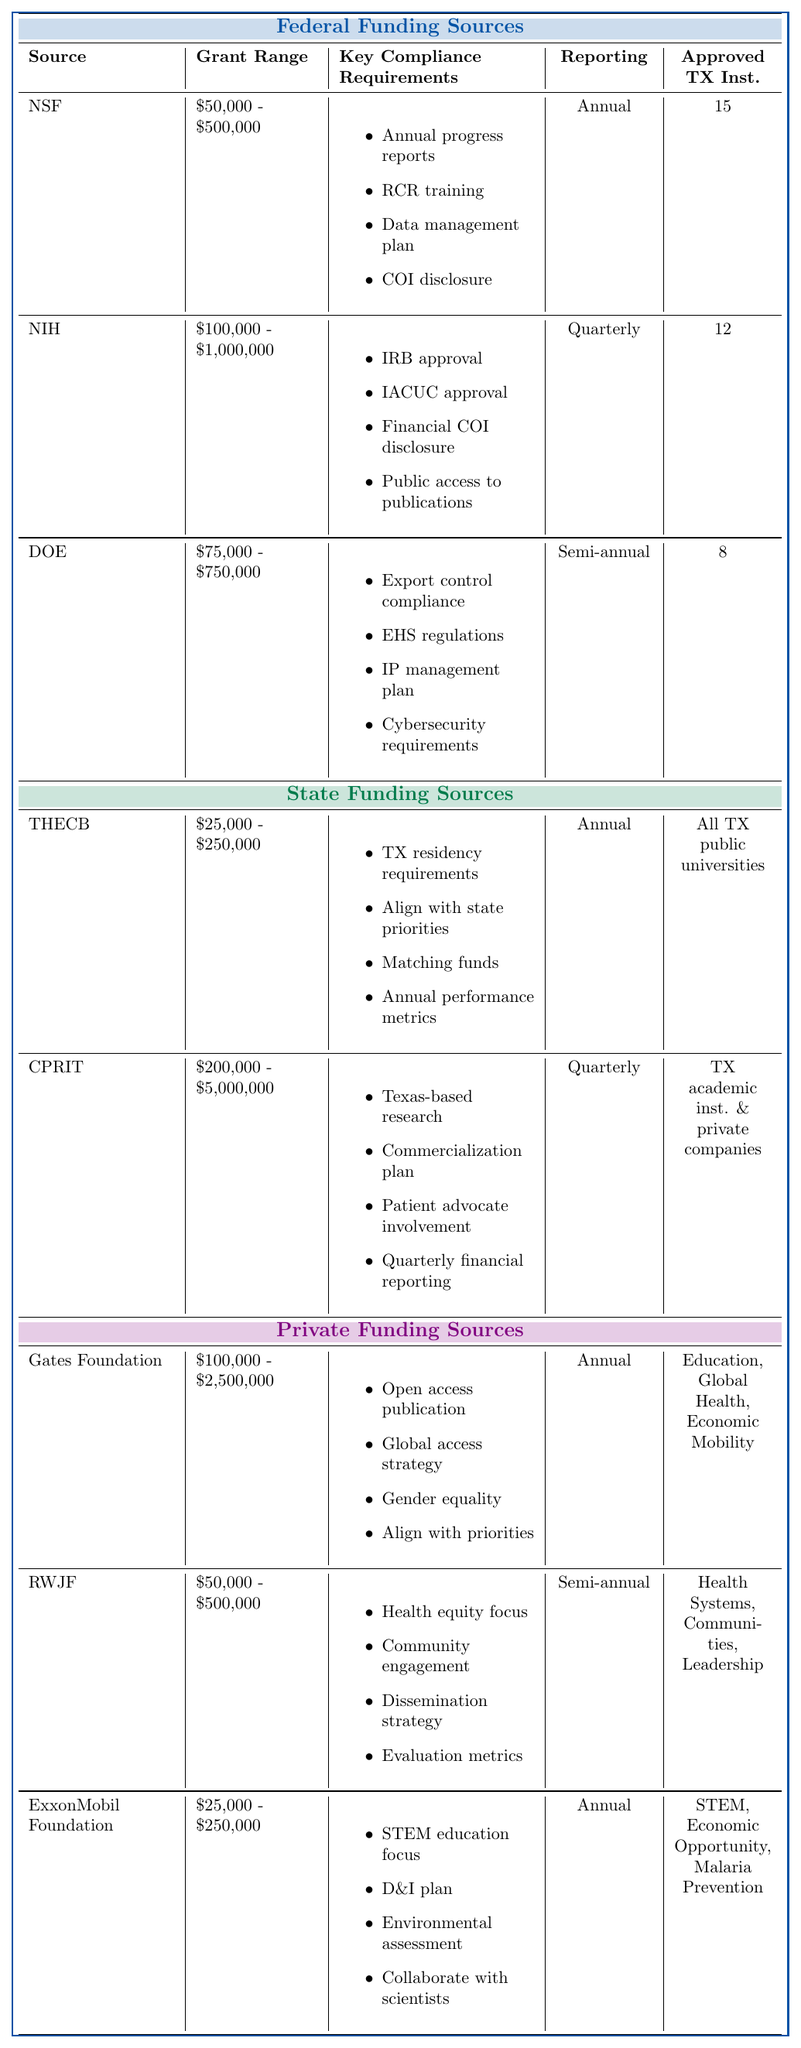What is the grant allocation range for the National Science Foundation (NSF)? The table lists the grant allocation range for NSF as $50,000 - $500,000.
Answer: $50,000 - $500,000 How often do researchers need to report for National Institutes of Health (NIH) grants? According to the table, the reporting frequency for NIH is quarterly.
Answer: Quarterly Which funding source requires a commercialization plan? The Cancer Prevention and Research Institute of Texas (CPRIT) requires a commercialization plan, as indicated in the compliance requirements.
Answer: Cancer Prevention and Research Institute of Texas (CPRIT) Are there more approved Texas institutions for the National Science Foundation (NSF) than for the Department of Energy (DOE)? NSF has 15 approved institutions while DOE has 8. Since 15 is greater than 8, the answer is yes.
Answer: Yes What is the reporting frequency for the Robert Wood Johnson Foundation (RWJF)? The table indicates that the reporting frequency for RWJF is semi-annual.
Answer: Semi-annual How many grant allocation ranges exceed $1,000,000? Examining the ranges, only CPRIT has a maximum of $5,000,000. Therefore, there is only one grant allocation range that exceeds $1,000,000.
Answer: 1 Which funding source has the smallest grant allocation range? The ExxonMobil Foundation has the smallest range of $25,000 - $250,000 when compared to others.
Answer: ExxonMobil Foundation Is it true that all state funding sources have an annual reporting frequency? The Texas Higher Education Coordinating Board (THECB) requires annual reporting, whereas CPRIT has a quarterly reporting frequency, making it false.
Answer: No What are the key compliance requirements for Federal Funding Sources as a whole? The key compliance requirements for Federal Funding Sources include: Annual progress reports, Responsible Conduct of Research training, Data management plan, Conflict of Interest disclosure, IRB approval, and more.
Answer: Varies by source How many Texas institutions are approved for NIH grants compared to the Gates Foundation? NIH has 12 approved Texas institutions while Gates Foundation does not specify a number but focuses on multiple areas. Thus, NIH has more approved institutions.
Answer: NIH has more (12 vs none specified) 